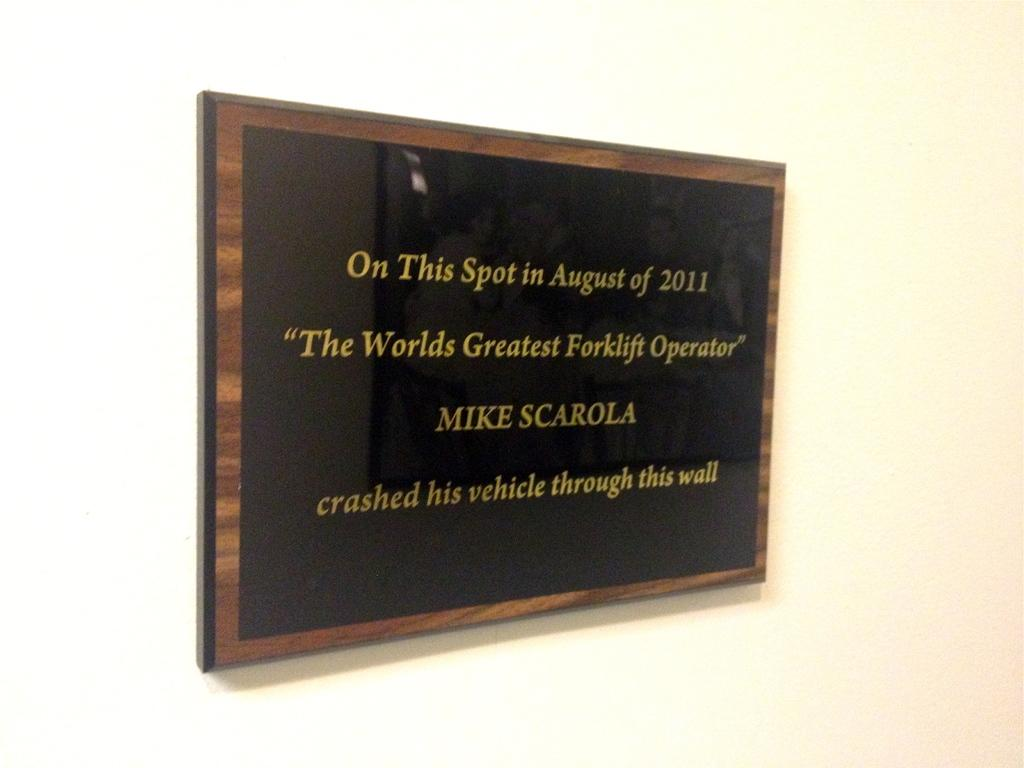Provide a one-sentence caption for the provided image. An award depicting a winner of a 2011 world's greatest forklift operator. 